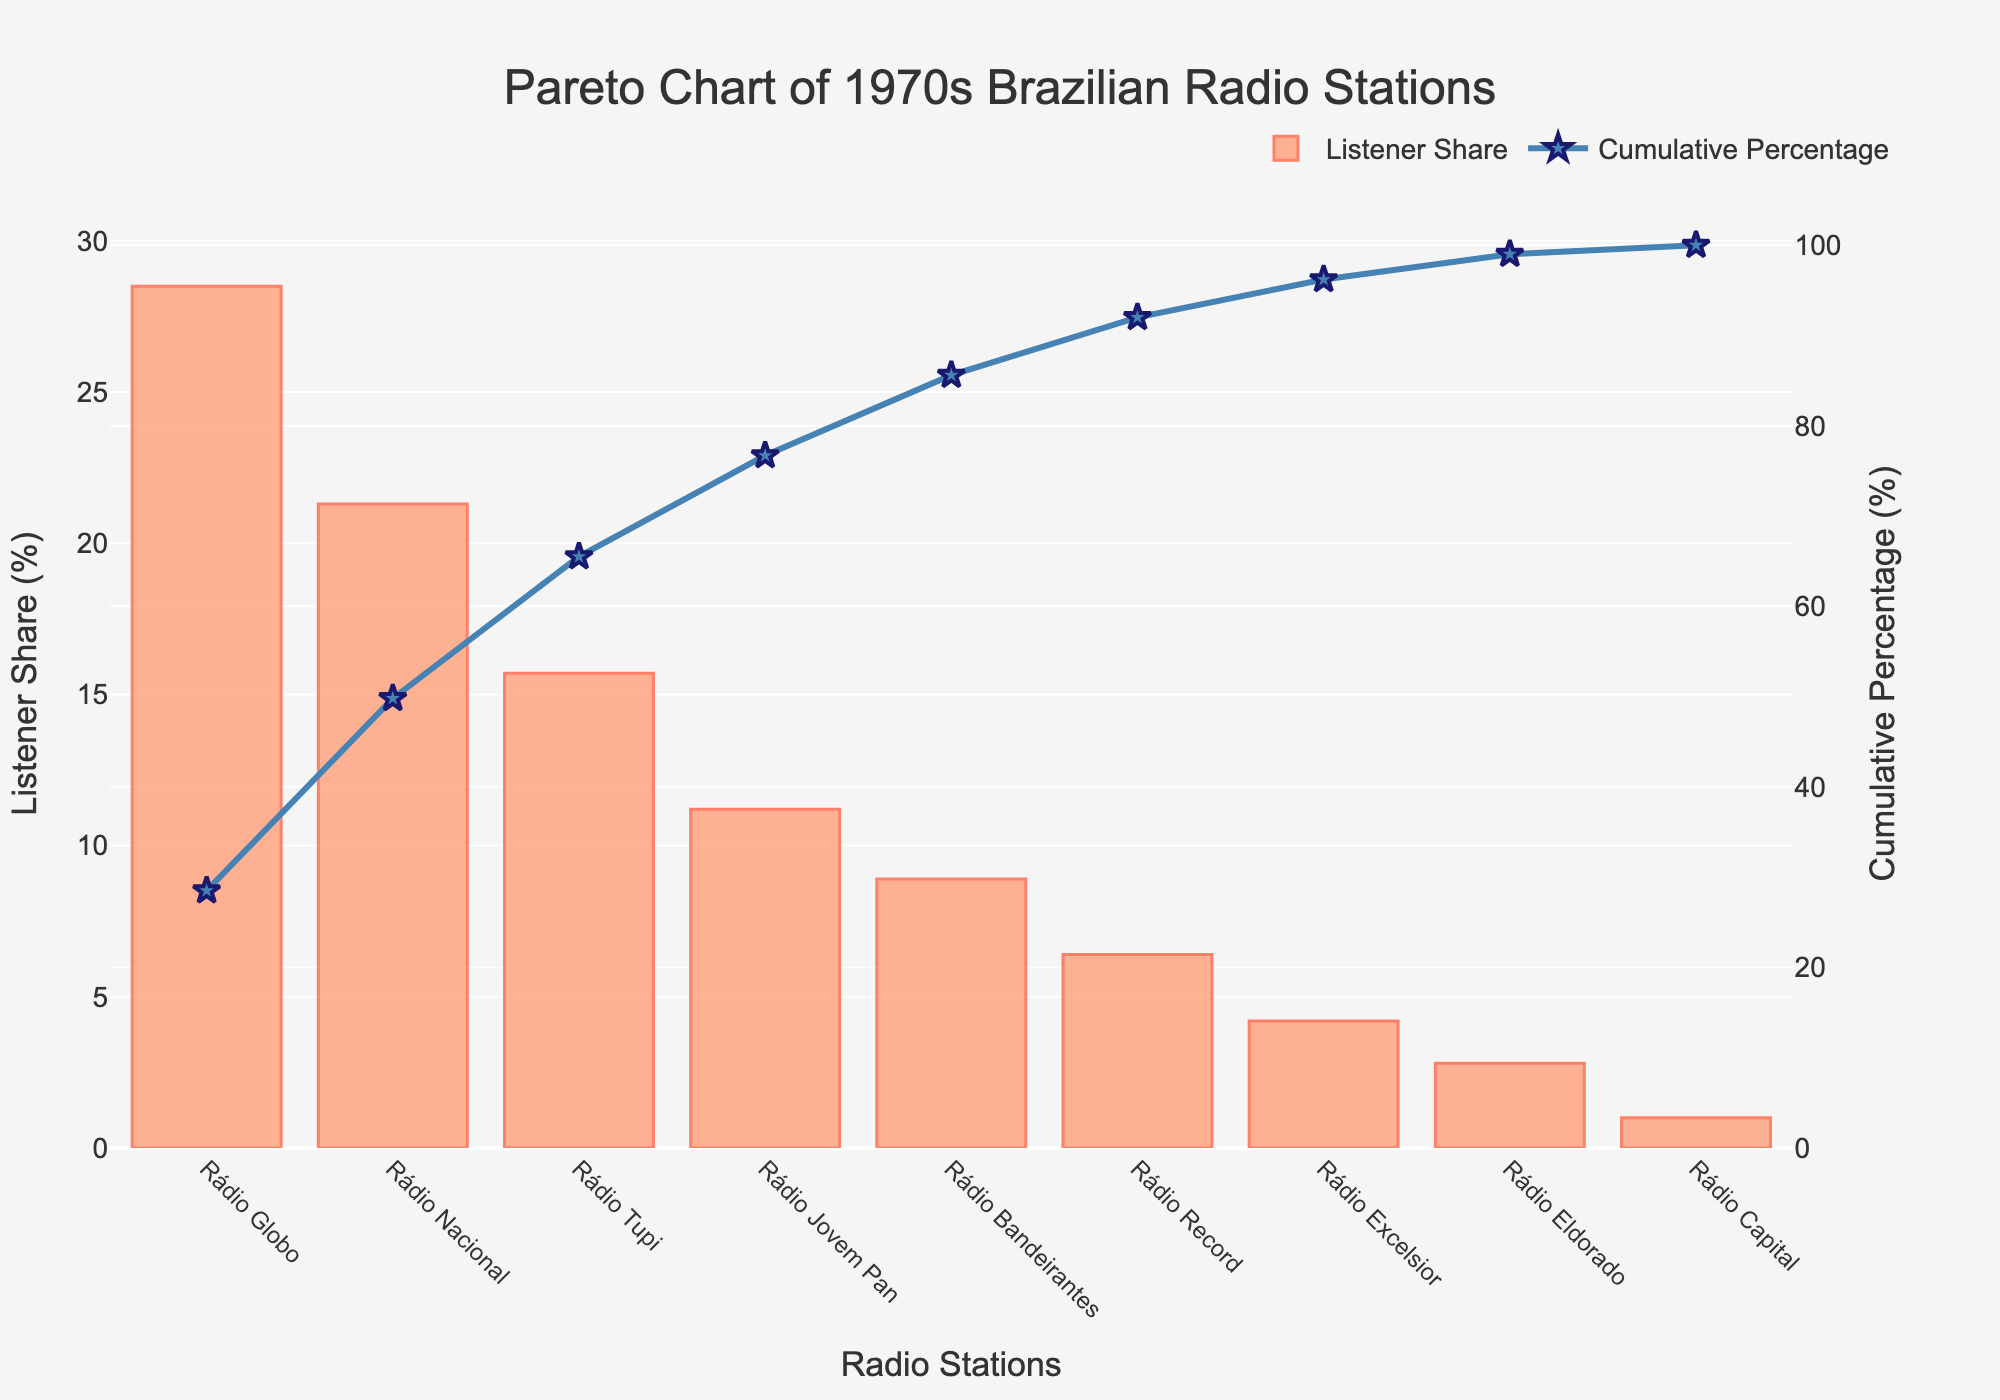how many radio stations are included in the chart? There are nine radio stations listed in the data table and plotted on the chart as indicated by the bars representing each station.
Answer: 9 which radio station has the highest listener share? The listener share is given by the height of the bars in the chart. The tallest bar represents Rádio Globo, indicating it has the highest listener share of 28.5%.
Answer: Rádio Globo what is the cumulative percentage of the top three radio stations? The cumulative percentages are shown by the line graph. For the top three radio stations - Rádio Globo, Rádio Nacional, and Rádio Tupi - their cumulative percentages are 28.5%, 49.8%, and 65.5% respectively. Adding these gives 65.5%.
Answer: 65.5% how does the listener share of Rádio Bandeirantes compare to Rádio Jovem Pan? Rádio Jovem Pan has a listener share of 11.2% and Rádio Bandeirantes has a share of 8.9%. By comparing these two values, we see that Rádio Jovem Pan has a higher listener share than Rádio Bandeirantes.
Answer: Rádio Jovem Pan has a higher share which radio stations contribute to achieving over 50% cumulative listener share? The cumulative percentage line crosses the 50% mark at Rádio Nacional. Hence Rádio Globo and Rádio Nacional contribute to achieving over 50% cumulative listener share.
Answer: Rádio Globo and Rádio Nacional what percentage of listener share does Rádio Record have? The bar representing Rádio Record shows that it has a listener share of 6.4%.
Answer: 6.4% what is the cumulative percentage after adding Rádio Excelsior? Adding up the listener shares for Rádio Globo (28.5%), Rádio Nacional (21.3%), Rádio Tupi (15.7%), Rádio Jovem Pan (11.2%), Rádio Bandeirantes (8.9%), and Rádio Excelsior (4.2%) gives us a cumulative percentage of 89.8%.
Answer: 89.8% is Rádio Capital's listener share above or below the average listener share of all stations? The average listener share can be calculated by summing all listener shares and dividing by the number of stations. The total listener share is 100%, therefore the average is 100% / 9 ≈ 11.1%. Rádio Capital's share is 1.0%, which is below the average.
Answer: Below which stations have a listener share less than 10%? From the chart, Rádio Bandeirantes, Rádio Record, Rádio Excelsior, Rádio Eldorado, and Rádio Capital all have listener shares less than 10%.
Answer: Rádio Bandeirantes, Rádio Record, Rádio Excelsior, Rádio Eldorado, Rádio Capital 